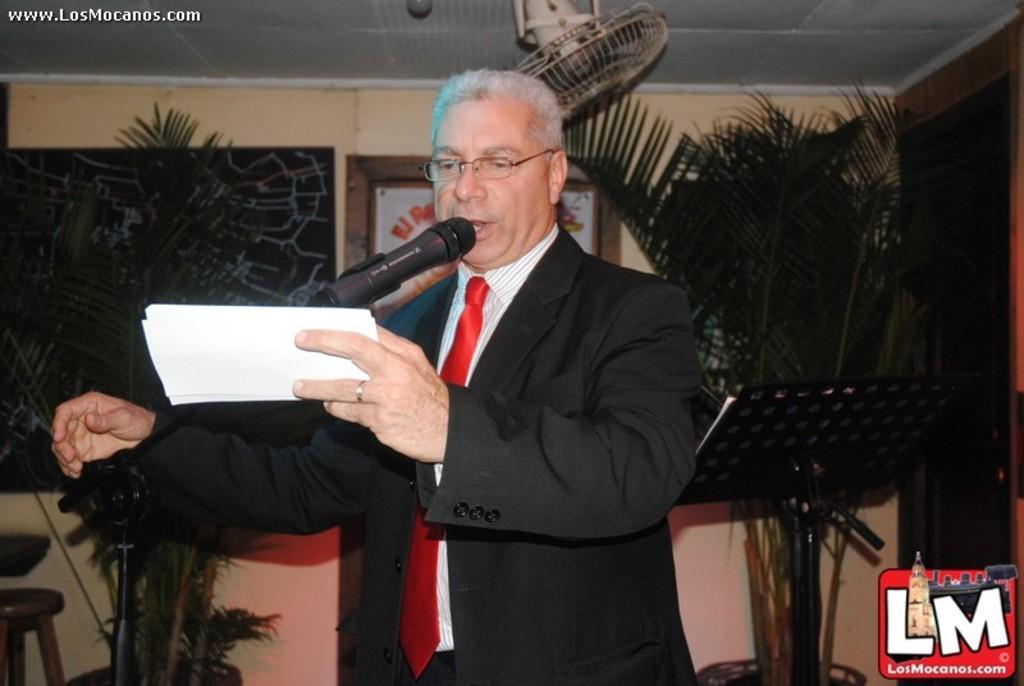Could you give a brief overview of what you see in this image? In this image we can see a person standing with the paper. In the background we can see board, plants, fan, photo frame and wall. 